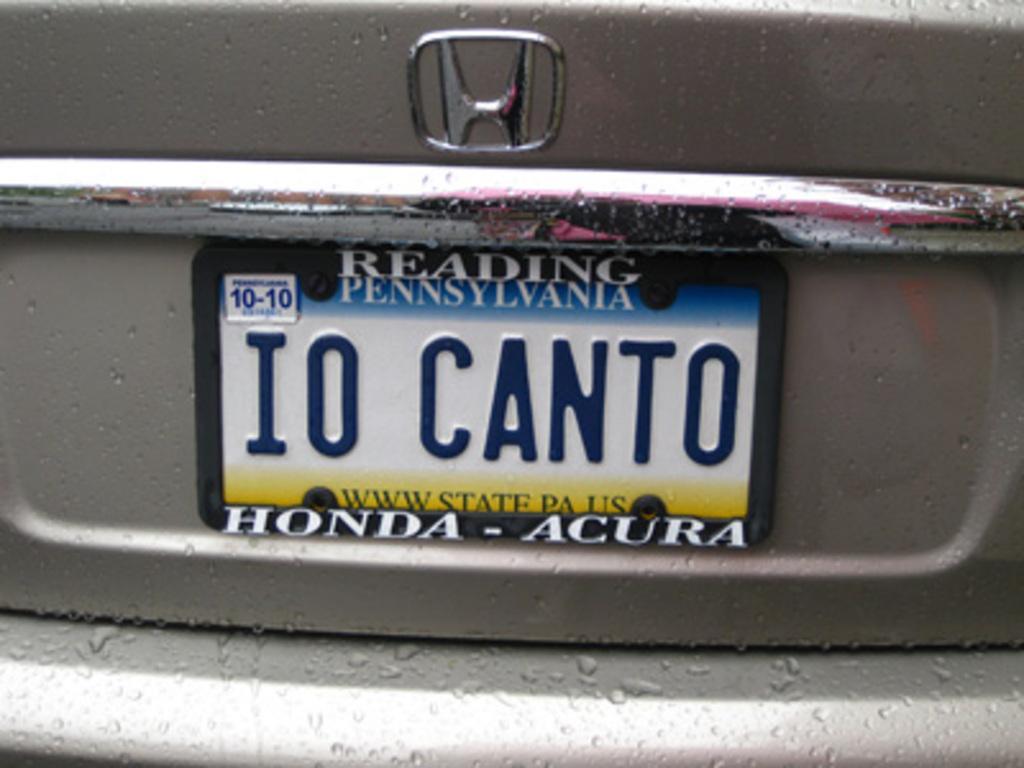Describe this image in one or two sentences. We can see vehicle, number plate and logo. 